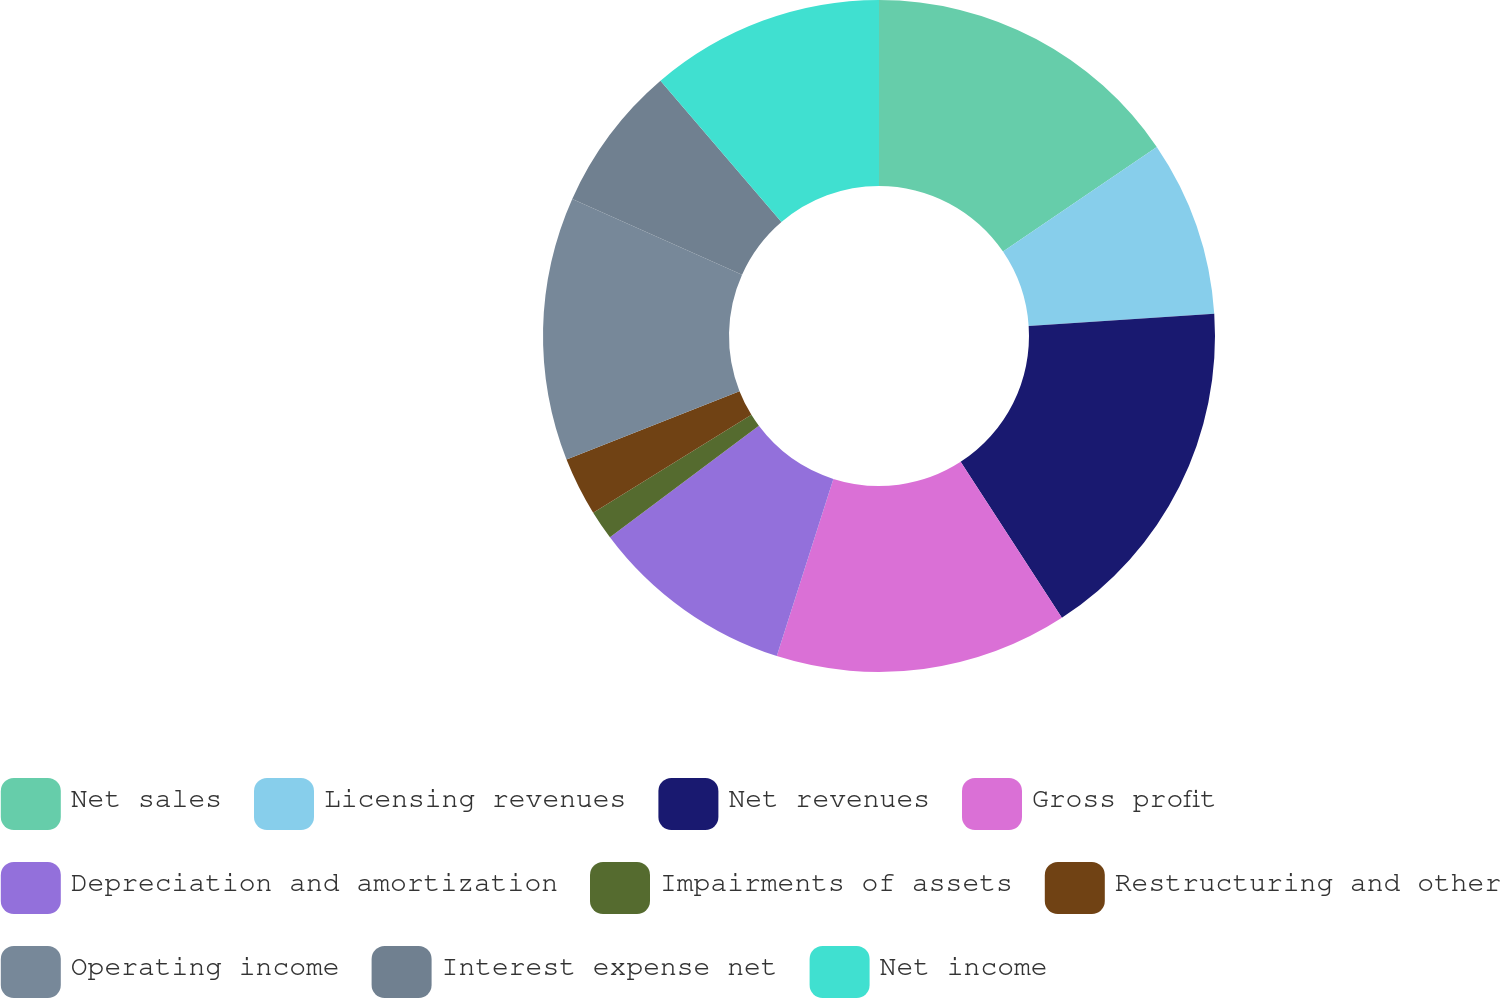<chart> <loc_0><loc_0><loc_500><loc_500><pie_chart><fcel>Net sales<fcel>Licensing revenues<fcel>Net revenues<fcel>Gross profit<fcel>Depreciation and amortization<fcel>Impairments of assets<fcel>Restructuring and other<fcel>Operating income<fcel>Interest expense net<fcel>Net income<nl><fcel>15.49%<fcel>8.45%<fcel>16.9%<fcel>14.08%<fcel>9.86%<fcel>1.41%<fcel>2.82%<fcel>12.68%<fcel>7.04%<fcel>11.27%<nl></chart> 